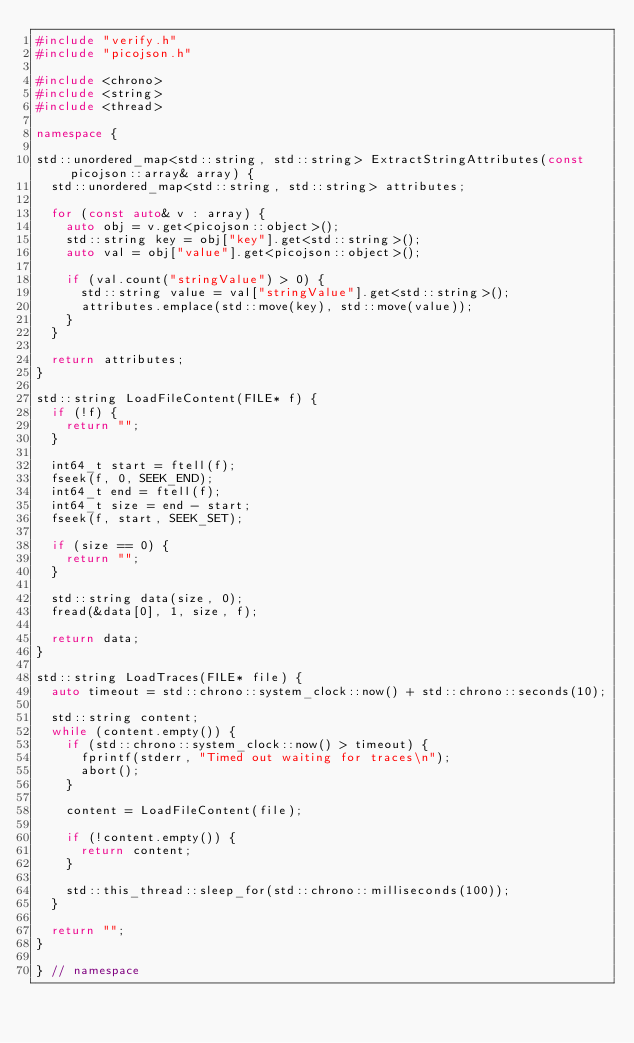Convert code to text. <code><loc_0><loc_0><loc_500><loc_500><_C++_>#include "verify.h"
#include "picojson.h"

#include <chrono>
#include <string>
#include <thread>

namespace {

std::unordered_map<std::string, std::string> ExtractStringAttributes(const picojson::array& array) {
  std::unordered_map<std::string, std::string> attributes;

  for (const auto& v : array) {
    auto obj = v.get<picojson::object>();
    std::string key = obj["key"].get<std::string>();
    auto val = obj["value"].get<picojson::object>();

    if (val.count("stringValue") > 0) {
      std::string value = val["stringValue"].get<std::string>();
      attributes.emplace(std::move(key), std::move(value));
    }
  }

  return attributes;
}

std::string LoadFileContent(FILE* f) {
  if (!f) {
    return "";
  }

  int64_t start = ftell(f);
  fseek(f, 0, SEEK_END);
  int64_t end = ftell(f);
  int64_t size = end - start;
  fseek(f, start, SEEK_SET);

  if (size == 0) {
    return "";
  }

  std::string data(size, 0);
  fread(&data[0], 1, size, f);

  return data;
}

std::string LoadTraces(FILE* file) {
  auto timeout = std::chrono::system_clock::now() + std::chrono::seconds(10);

  std::string content;
  while (content.empty()) {
    if (std::chrono::system_clock::now() > timeout) {
      fprintf(stderr, "Timed out waiting for traces\n");
      abort();
    }

    content = LoadFileContent(file);

    if (!content.empty()) {
      return content;
    }

    std::this_thread::sleep_for(std::chrono::milliseconds(100));
  }

  return "";
}

} // namespace
</code> 